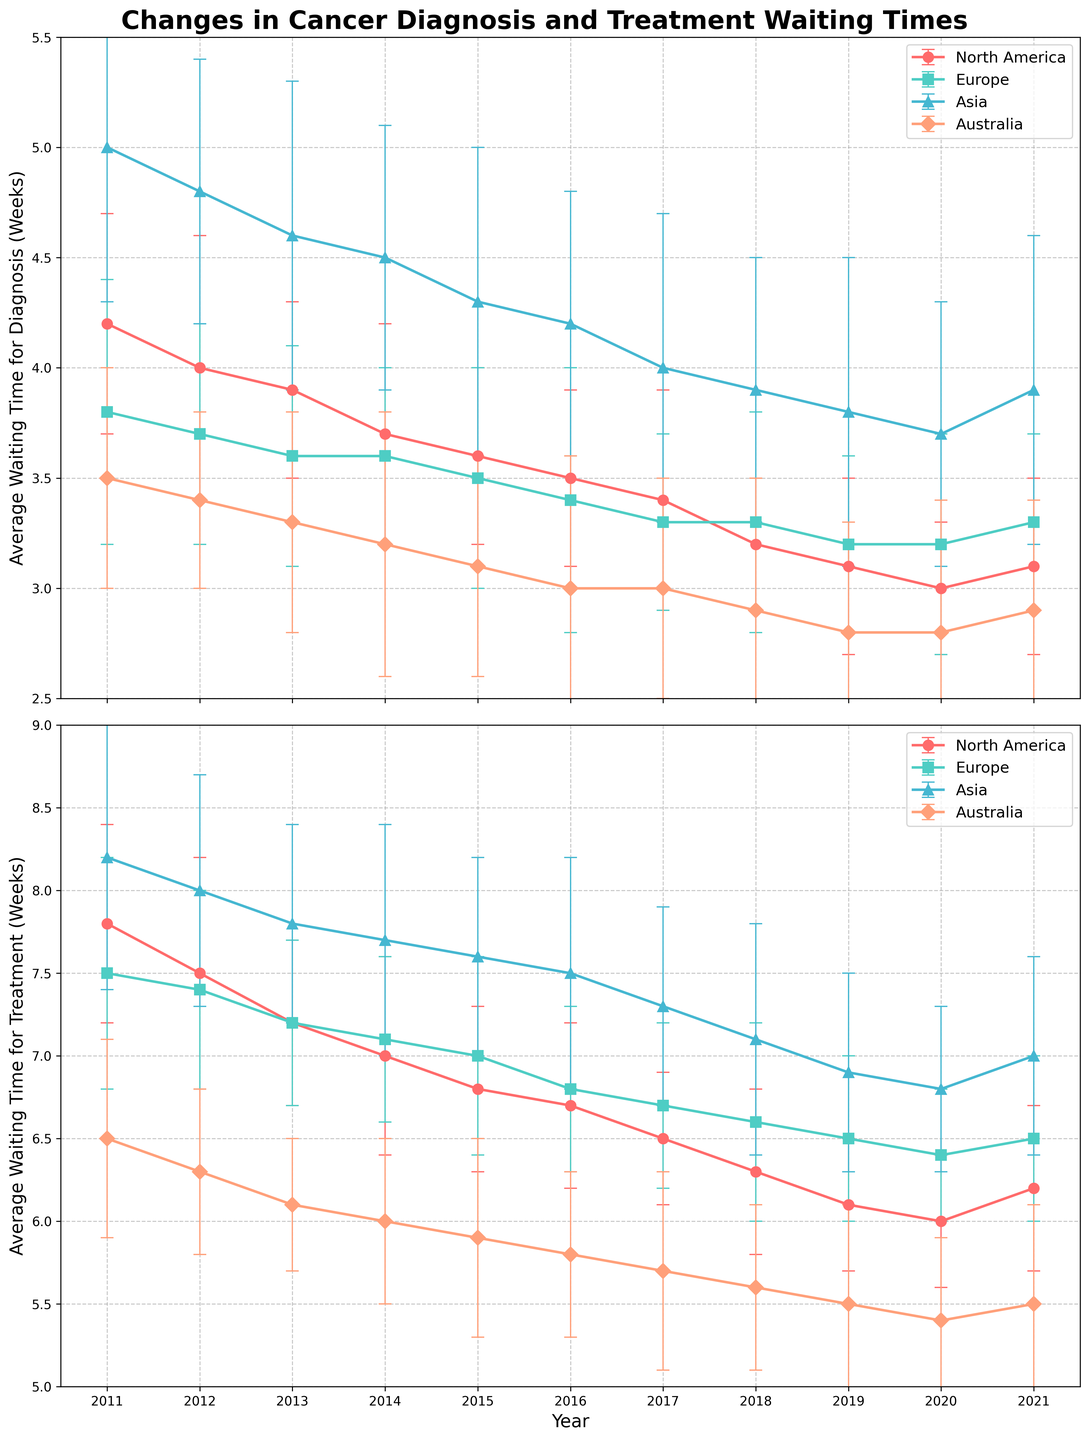What is the title of the figure? The title of the figure is located at the top center of the plot. It provides an overview of what the graph represents.
Answer: Changes in Cancer Diagnosis and Treatment Waiting Times Over which years is the data plotted on the x-axis? The x-axis is labeled with years. The tick marks show the range of years included in the data.
Answer: 2011 to 2021 Which region shows the longest average waiting time for cancer diagnosis in 2011? Analyze the different lines and data points on the diagnosis plot for the year 2011. Identify the region with the highest average waiting time.
Answer: Asia By how many weeks did the average waiting time for diagnosis decrease in North America from 2011 to 2021? Subtract the average waiting time for diagnosis in North America in 2021 from that in 2011.
Answer: 1.1 weeks Which region showed the smallest change in average waiting time for treatment over the decade? Compare the change in average waiting time for treatment from 2011 to 2021 between the different regions.
Answer: Europe In which year did Australia have its lowest average waiting time for treatment? Examine the data points and lines representing Australia in the treatment plot to find the year with the lowest average waiting time.
Answer: 2020 What trend do you observe for Europe’s average waiting time for diagnosis over the decade? Look at the line representing Europe in the diagnosis plot and observe if it shows an increasing, decreasing, or stable trend over the decade.
Answer: Slightly decreasing trend Compare the average waiting time for treatment in North America and Europe in 2020. Which region had a higher average, and by how much? Find the data points for North America and Europe in 2020 on the treatment plot and calculate the difference.
Answer: Europe had a higher average by 0.4 weeks Considering both diagnosis and treatment, which region showed a consistent improvement over the decade? Analyze the trends in both diagnosis and treatment plots for each region to determine which one consistently improved over the decade.
Answer: North America 